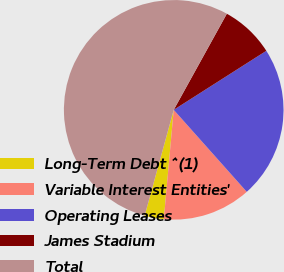<chart> <loc_0><loc_0><loc_500><loc_500><pie_chart><fcel>Long-Term Debt ^(1)<fcel>Variable Interest Entities'<fcel>Operating Leases<fcel>James Stadium<fcel>Total<nl><fcel>2.83%<fcel>13.02%<fcel>22.45%<fcel>7.93%<fcel>53.77%<nl></chart> 